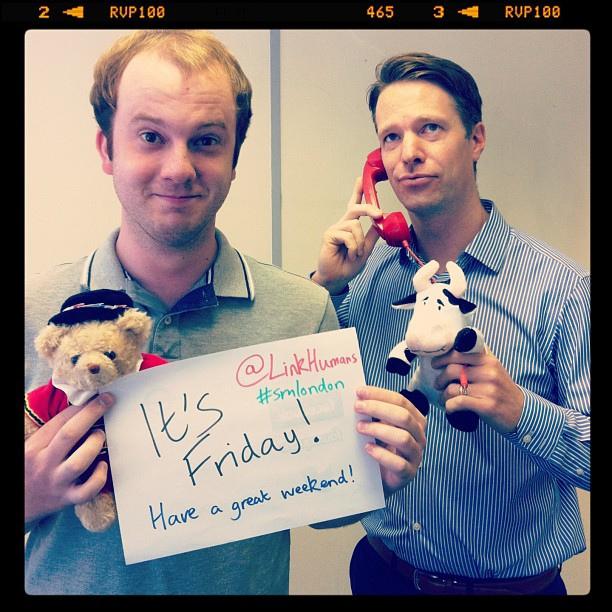What day does the sign say it is?
Write a very short answer. Friday. What is the word at the top?
Be succinct. It's. What color is the person's phone?
Short answer required. Red. What is the man on the left looking at?
Short answer required. Camera. 